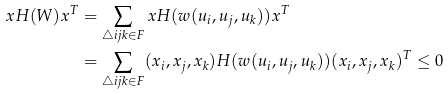<formula> <loc_0><loc_0><loc_500><loc_500>x H ( W ) x ^ { T } & = \sum _ { \triangle i j k \in F } x H ( w ( u _ { i } , u _ { j } , u _ { k } ) ) x ^ { T } \\ & = \sum _ { \triangle i j k \in F } ( x _ { i } , x _ { j } , x _ { k } ) H ( w ( u _ { i } , u _ { j } , u _ { k } ) ) ( x _ { i } , x _ { j } , x _ { k } ) ^ { T } \leq 0</formula> 